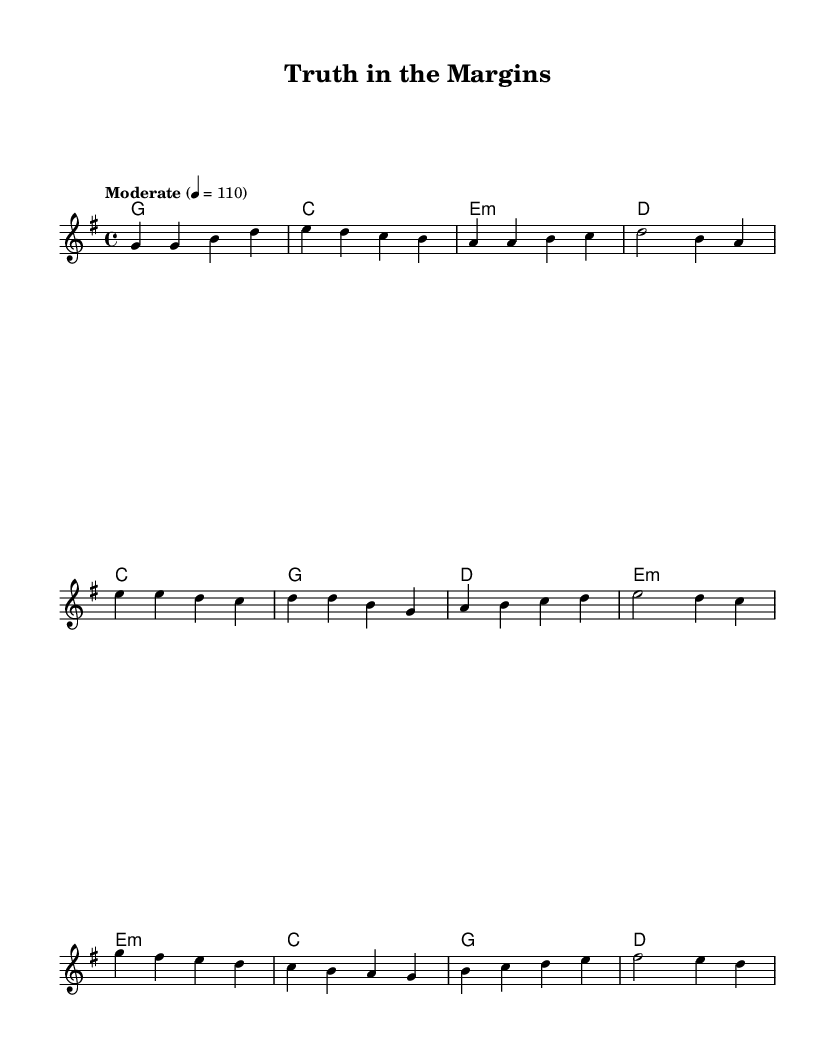What is the key signature of this music? The key signature is G major, which has one sharp (F#). This can be determined by looking at the key signature indicated at the beginning of the sheet.
Answer: G major What is the time signature of this music? The time signature is 4/4, indicated at the beginning of the sheet music. This means there are four beats in a measure and the quarter note gets one beat.
Answer: 4/4 What is the tempo marking of this piece? The tempo marking is "Moderate" at a speed of 110 beats per minute. This information is provided directly above the staff in the tempo indication.
Answer: Moderate 4 = 110 How many measures are in the verse section? The verse section consists of four measures, as indicated by the grouping of notes in that part of the sheet music. You can count each complete set of notes before encountering a double bar line or transition.
Answer: 4 What chords are used in the chorus? The chords used in the chorus are C, G, D, and E minor, as indicated by the chord symbols placed above the staff in the respective measures.
Answer: C, G, D, E minor What is the pattern of the melody in the bridge? The melody in the bridge descends through a series of notes starting from G down to D, showcasing a downward motion that matches the emotional context typically associated with bridge sections in songs.
Answer: Descending How many unique chords are present in the entire piece? There are six unique chords present: G, C, E minor, D, B, and F sharp minor. By analyzing the chord changes listed above the staff, we can identify each distinct chord used throughout the music.
Answer: 6 